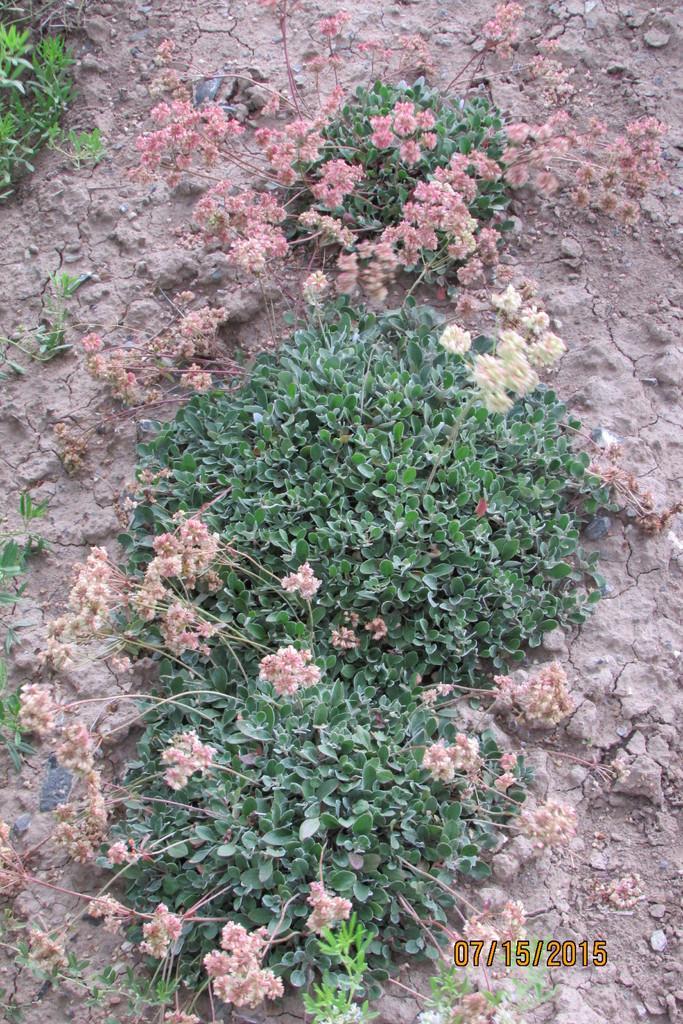Describe this image in one or two sentences. There are plants with flowers on the ground. In the right bottom corner there is a watermark. 